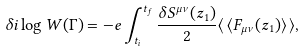Convert formula to latex. <formula><loc_0><loc_0><loc_500><loc_500>\delta i \log W ( \Gamma ) = - { e } \int _ { t _ { i } } ^ { t _ { f } } { \frac { \delta S ^ { \mu \nu } ( z _ { 1 } ) } { 2 } } \langle \, \langle F _ { \mu \nu } ( z _ { 1 } ) \rangle \, \rangle ,</formula> 